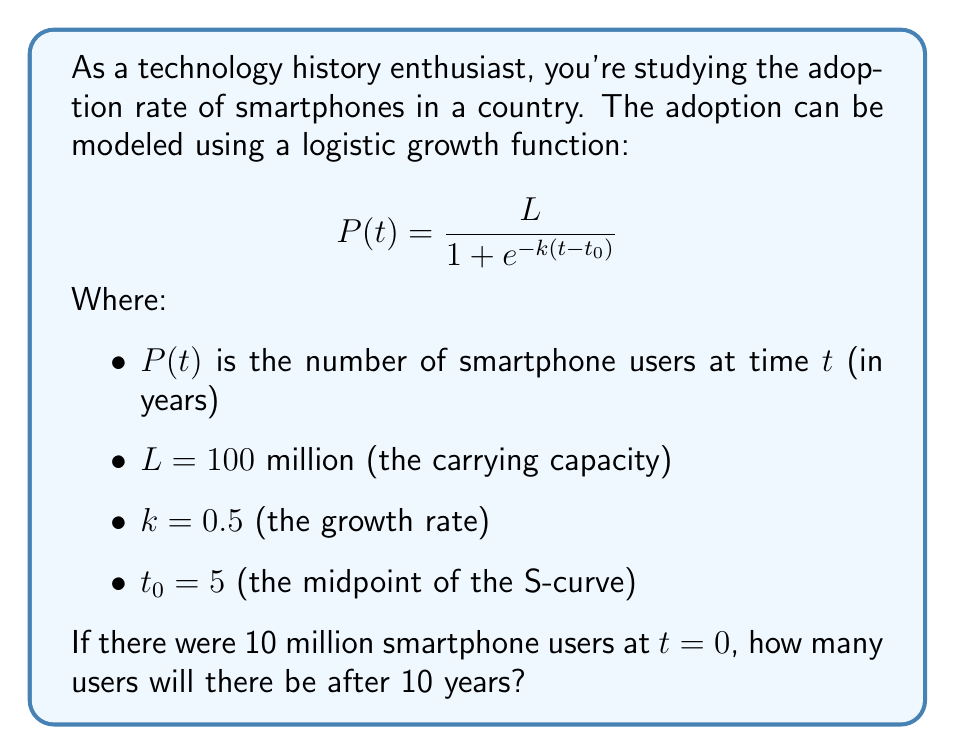Provide a solution to this math problem. To solve this problem, we'll follow these steps:

1) First, we need to find the initial value of $e^{-k(t-t_0)}$ at $t = 0$. We can do this by rearranging the logistic function equation:

   $$10 = \frac{100}{1 + e^{-0.5(0-5)}}$$
   $$10(1 + e^{2.5}) = 100$$
   $$e^{2.5} = 9$$

2) Now, we can use this to write our specific logistic function:

   $$P(t) = \frac{100}{1 + 9e^{-0.5t}}$$

3) To find the number of users after 10 years, we substitute $t = 10$ into this equation:

   $$P(10) = \frac{100}{1 + 9e^{-0.5(10)}}$$

4) Let's solve this step by step:
   
   $$P(10) = \frac{100}{1 + 9e^{-5}}$$
   $$= \frac{100}{1 + 9(0.00674)}$$
   $$= \frac{100}{1 + 0.06066}$$
   $$= \frac{100}{1.06066}$$
   $$= 94.28$$

5) Rounding to the nearest million:

   $P(10) \approx 94$ million users
Answer: After 10 years, there will be approximately 94 million smartphone users. 